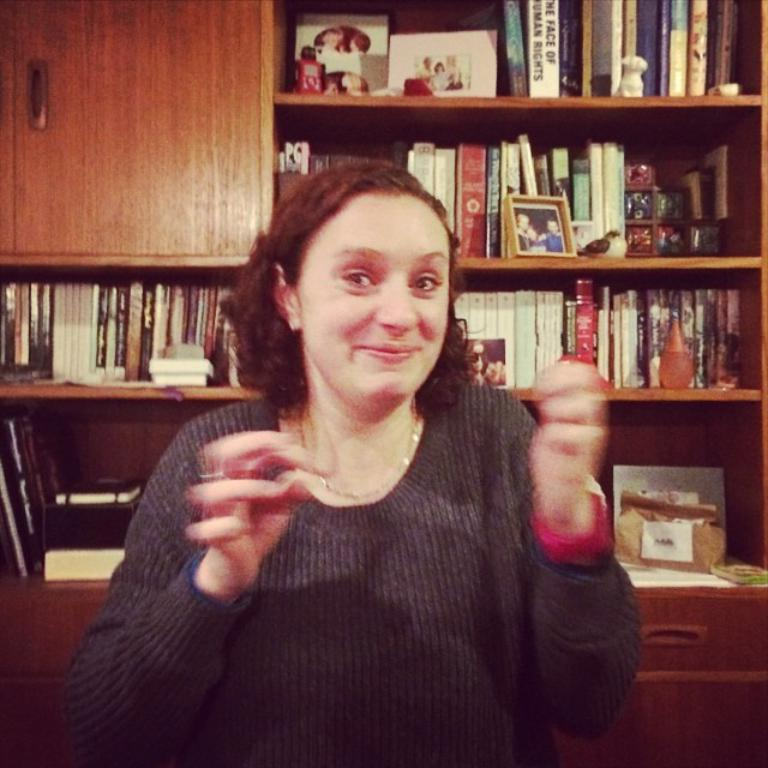Who is present in the image? There is a woman in the image. What can be seen in the background of the image? There are books in the background of the image, kept in racks. Can you describe the furniture in the image? There is a cupboard on the top left of the image and drawers at the bottom of the image. What type of steam is coming out of the woman's ears in the image? There is no steam coming out of the woman's ears in the image, as this detail is not mentioned in the provided facts. 